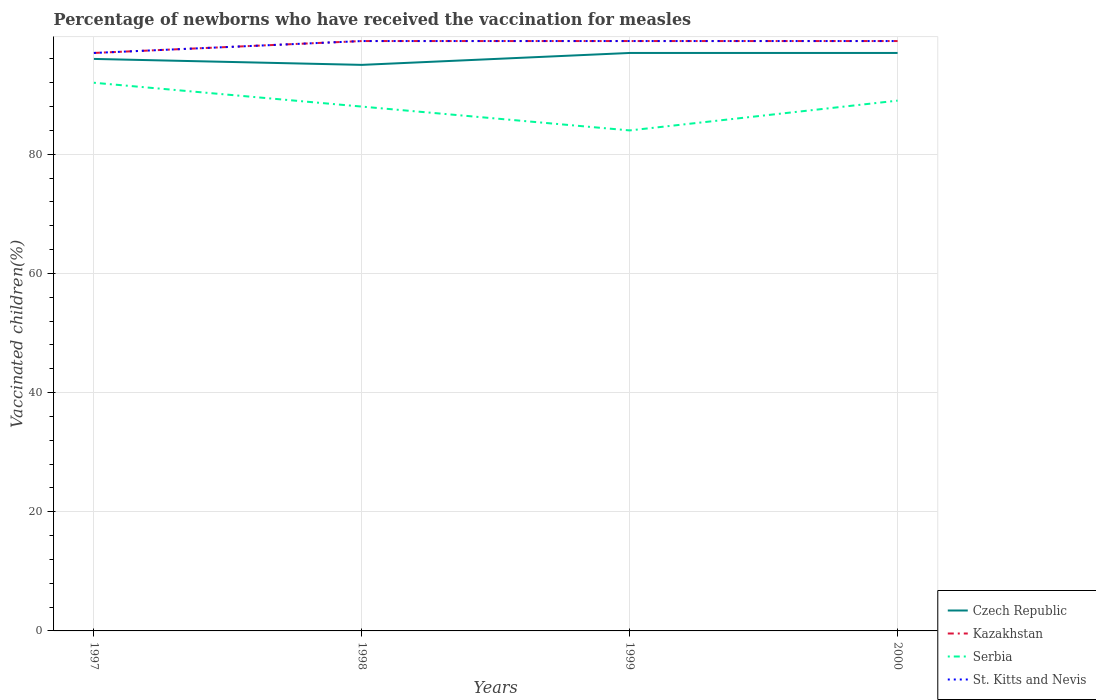How many different coloured lines are there?
Provide a succinct answer. 4. Is the number of lines equal to the number of legend labels?
Your answer should be very brief. Yes. Across all years, what is the maximum percentage of vaccinated children in Kazakhstan?
Offer a very short reply. 97. What is the difference between the highest and the second highest percentage of vaccinated children in Serbia?
Offer a terse response. 8. Does the graph contain grids?
Provide a short and direct response. Yes. How many legend labels are there?
Make the answer very short. 4. How are the legend labels stacked?
Keep it short and to the point. Vertical. What is the title of the graph?
Give a very brief answer. Percentage of newborns who have received the vaccination for measles. Does "Chad" appear as one of the legend labels in the graph?
Offer a very short reply. No. What is the label or title of the Y-axis?
Provide a succinct answer. Vaccinated children(%). What is the Vaccinated children(%) of Czech Republic in 1997?
Offer a terse response. 96. What is the Vaccinated children(%) in Kazakhstan in 1997?
Make the answer very short. 97. What is the Vaccinated children(%) of Serbia in 1997?
Give a very brief answer. 92. What is the Vaccinated children(%) in St. Kitts and Nevis in 1997?
Provide a succinct answer. 97. What is the Vaccinated children(%) in Czech Republic in 1998?
Your answer should be compact. 95. What is the Vaccinated children(%) in St. Kitts and Nevis in 1998?
Make the answer very short. 99. What is the Vaccinated children(%) of Czech Republic in 1999?
Your response must be concise. 97. What is the Vaccinated children(%) in Serbia in 1999?
Provide a succinct answer. 84. What is the Vaccinated children(%) in St. Kitts and Nevis in 1999?
Your answer should be very brief. 99. What is the Vaccinated children(%) in Czech Republic in 2000?
Make the answer very short. 97. What is the Vaccinated children(%) of Kazakhstan in 2000?
Provide a short and direct response. 99. What is the Vaccinated children(%) of Serbia in 2000?
Offer a terse response. 89. What is the Vaccinated children(%) of St. Kitts and Nevis in 2000?
Offer a terse response. 99. Across all years, what is the maximum Vaccinated children(%) in Czech Republic?
Provide a short and direct response. 97. Across all years, what is the maximum Vaccinated children(%) of Serbia?
Keep it short and to the point. 92. Across all years, what is the minimum Vaccinated children(%) in Czech Republic?
Offer a terse response. 95. Across all years, what is the minimum Vaccinated children(%) in Kazakhstan?
Provide a succinct answer. 97. Across all years, what is the minimum Vaccinated children(%) in St. Kitts and Nevis?
Ensure brevity in your answer.  97. What is the total Vaccinated children(%) of Czech Republic in the graph?
Provide a short and direct response. 385. What is the total Vaccinated children(%) of Kazakhstan in the graph?
Your answer should be very brief. 394. What is the total Vaccinated children(%) in Serbia in the graph?
Offer a terse response. 353. What is the total Vaccinated children(%) in St. Kitts and Nevis in the graph?
Your response must be concise. 394. What is the difference between the Vaccinated children(%) of Serbia in 1997 and that in 1998?
Provide a succinct answer. 4. What is the difference between the Vaccinated children(%) of Czech Republic in 1997 and that in 1999?
Make the answer very short. -1. What is the difference between the Vaccinated children(%) of Kazakhstan in 1997 and that in 1999?
Offer a terse response. -2. What is the difference between the Vaccinated children(%) in Kazakhstan in 1997 and that in 2000?
Offer a very short reply. -2. What is the difference between the Vaccinated children(%) of Kazakhstan in 1998 and that in 2000?
Provide a succinct answer. 0. What is the difference between the Vaccinated children(%) of Czech Republic in 1999 and that in 2000?
Keep it short and to the point. 0. What is the difference between the Vaccinated children(%) in Czech Republic in 1997 and the Vaccinated children(%) in Serbia in 1998?
Your response must be concise. 8. What is the difference between the Vaccinated children(%) in Serbia in 1997 and the Vaccinated children(%) in St. Kitts and Nevis in 1998?
Make the answer very short. -7. What is the difference between the Vaccinated children(%) in Czech Republic in 1997 and the Vaccinated children(%) in Serbia in 1999?
Offer a very short reply. 12. What is the difference between the Vaccinated children(%) in Kazakhstan in 1997 and the Vaccinated children(%) in Serbia in 1999?
Make the answer very short. 13. What is the difference between the Vaccinated children(%) of Kazakhstan in 1997 and the Vaccinated children(%) of St. Kitts and Nevis in 1999?
Keep it short and to the point. -2. What is the difference between the Vaccinated children(%) in Czech Republic in 1997 and the Vaccinated children(%) in Serbia in 2000?
Give a very brief answer. 7. What is the difference between the Vaccinated children(%) of Kazakhstan in 1997 and the Vaccinated children(%) of Serbia in 2000?
Keep it short and to the point. 8. What is the difference between the Vaccinated children(%) in Kazakhstan in 1997 and the Vaccinated children(%) in St. Kitts and Nevis in 2000?
Offer a terse response. -2. What is the difference between the Vaccinated children(%) in Czech Republic in 1998 and the Vaccinated children(%) in Kazakhstan in 1999?
Provide a succinct answer. -4. What is the difference between the Vaccinated children(%) in Kazakhstan in 1998 and the Vaccinated children(%) in Serbia in 1999?
Provide a succinct answer. 15. What is the difference between the Vaccinated children(%) in Kazakhstan in 1998 and the Vaccinated children(%) in Serbia in 2000?
Provide a succinct answer. 10. What is the difference between the Vaccinated children(%) in Serbia in 1998 and the Vaccinated children(%) in St. Kitts and Nevis in 2000?
Your answer should be very brief. -11. What is the difference between the Vaccinated children(%) of Czech Republic in 1999 and the Vaccinated children(%) of Serbia in 2000?
Your answer should be compact. 8. What is the difference between the Vaccinated children(%) of Kazakhstan in 1999 and the Vaccinated children(%) of St. Kitts and Nevis in 2000?
Make the answer very short. 0. What is the average Vaccinated children(%) in Czech Republic per year?
Offer a terse response. 96.25. What is the average Vaccinated children(%) in Kazakhstan per year?
Keep it short and to the point. 98.5. What is the average Vaccinated children(%) of Serbia per year?
Keep it short and to the point. 88.25. What is the average Vaccinated children(%) of St. Kitts and Nevis per year?
Offer a terse response. 98.5. In the year 1997, what is the difference between the Vaccinated children(%) of Czech Republic and Vaccinated children(%) of Kazakhstan?
Your response must be concise. -1. In the year 1997, what is the difference between the Vaccinated children(%) in Czech Republic and Vaccinated children(%) in Serbia?
Ensure brevity in your answer.  4. In the year 1997, what is the difference between the Vaccinated children(%) in Czech Republic and Vaccinated children(%) in St. Kitts and Nevis?
Give a very brief answer. -1. In the year 1997, what is the difference between the Vaccinated children(%) of Serbia and Vaccinated children(%) of St. Kitts and Nevis?
Offer a terse response. -5. In the year 1998, what is the difference between the Vaccinated children(%) of Czech Republic and Vaccinated children(%) of Serbia?
Your answer should be compact. 7. In the year 1998, what is the difference between the Vaccinated children(%) of Kazakhstan and Vaccinated children(%) of St. Kitts and Nevis?
Provide a short and direct response. 0. In the year 1998, what is the difference between the Vaccinated children(%) of Serbia and Vaccinated children(%) of St. Kitts and Nevis?
Your answer should be very brief. -11. In the year 1999, what is the difference between the Vaccinated children(%) in Kazakhstan and Vaccinated children(%) in St. Kitts and Nevis?
Make the answer very short. 0. In the year 2000, what is the difference between the Vaccinated children(%) in Czech Republic and Vaccinated children(%) in Kazakhstan?
Keep it short and to the point. -2. In the year 2000, what is the difference between the Vaccinated children(%) in Czech Republic and Vaccinated children(%) in Serbia?
Provide a succinct answer. 8. In the year 2000, what is the difference between the Vaccinated children(%) of Czech Republic and Vaccinated children(%) of St. Kitts and Nevis?
Offer a terse response. -2. In the year 2000, what is the difference between the Vaccinated children(%) in Serbia and Vaccinated children(%) in St. Kitts and Nevis?
Provide a succinct answer. -10. What is the ratio of the Vaccinated children(%) of Czech Republic in 1997 to that in 1998?
Offer a terse response. 1.01. What is the ratio of the Vaccinated children(%) of Kazakhstan in 1997 to that in 1998?
Make the answer very short. 0.98. What is the ratio of the Vaccinated children(%) of Serbia in 1997 to that in 1998?
Your answer should be very brief. 1.05. What is the ratio of the Vaccinated children(%) of St. Kitts and Nevis in 1997 to that in 1998?
Provide a succinct answer. 0.98. What is the ratio of the Vaccinated children(%) in Kazakhstan in 1997 to that in 1999?
Your response must be concise. 0.98. What is the ratio of the Vaccinated children(%) of Serbia in 1997 to that in 1999?
Provide a succinct answer. 1.1. What is the ratio of the Vaccinated children(%) of St. Kitts and Nevis in 1997 to that in 1999?
Provide a short and direct response. 0.98. What is the ratio of the Vaccinated children(%) in Kazakhstan in 1997 to that in 2000?
Your answer should be compact. 0.98. What is the ratio of the Vaccinated children(%) of Serbia in 1997 to that in 2000?
Ensure brevity in your answer.  1.03. What is the ratio of the Vaccinated children(%) in St. Kitts and Nevis in 1997 to that in 2000?
Your response must be concise. 0.98. What is the ratio of the Vaccinated children(%) of Czech Republic in 1998 to that in 1999?
Your response must be concise. 0.98. What is the ratio of the Vaccinated children(%) of Serbia in 1998 to that in 1999?
Give a very brief answer. 1.05. What is the ratio of the Vaccinated children(%) in Czech Republic in 1998 to that in 2000?
Offer a terse response. 0.98. What is the ratio of the Vaccinated children(%) in Serbia in 1998 to that in 2000?
Provide a short and direct response. 0.99. What is the ratio of the Vaccinated children(%) of Serbia in 1999 to that in 2000?
Provide a short and direct response. 0.94. What is the difference between the highest and the second highest Vaccinated children(%) of Czech Republic?
Your answer should be compact. 0. What is the difference between the highest and the lowest Vaccinated children(%) of Czech Republic?
Your response must be concise. 2. What is the difference between the highest and the lowest Vaccinated children(%) in St. Kitts and Nevis?
Provide a short and direct response. 2. 